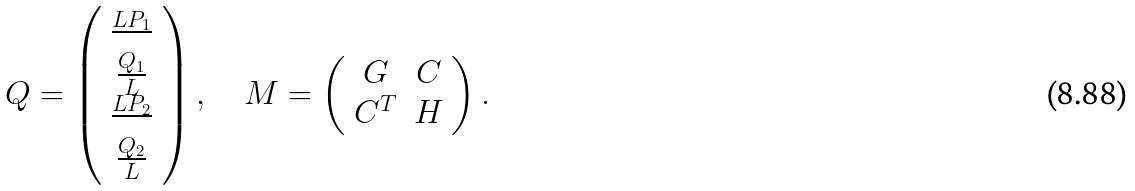<formula> <loc_0><loc_0><loc_500><loc_500>Q = \left ( \begin{array} { c } \frac { L P _ { 1 } } { } \\ \frac { Q _ { 1 } } { L } \\ \frac { L P _ { 2 } } { } \\ \frac { Q _ { 2 } } { L } \end{array} \right ) , \quad M = \left ( \begin{array} { c c } G & C \\ C ^ { T } & H \end{array} \right ) .</formula> 